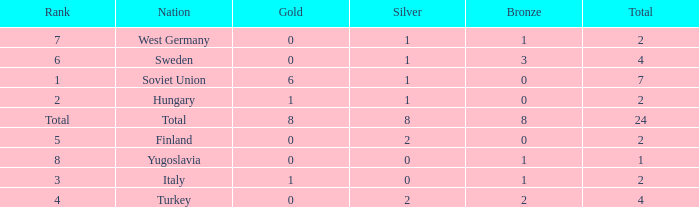What is the average Bronze, when Total is 7, and when Silver is greater than 1? None. 